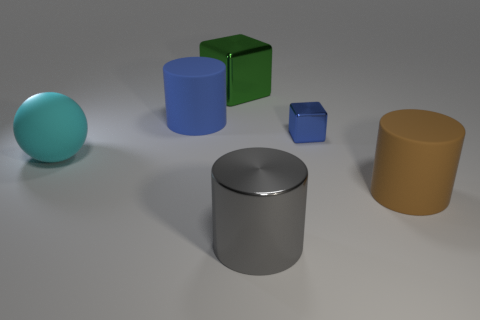Are there any other things that are the same color as the small thing?
Provide a succinct answer. Yes. There is a cylinder that is behind the tiny blue shiny object; does it have the same color as the cube that is in front of the blue matte cylinder?
Provide a short and direct response. Yes. Are there any big green blocks that have the same material as the large blue object?
Your answer should be very brief. No. Is the material of the gray object that is to the right of the green block the same as the green cube?
Your answer should be compact. Yes. There is a metal object that is both in front of the big blue rubber object and behind the big cyan object; what size is it?
Offer a very short reply. Small. The tiny metallic cube has what color?
Provide a succinct answer. Blue. How many big gray matte cylinders are there?
Make the answer very short. 0. How many large matte cylinders are the same color as the small metal cube?
Ensure brevity in your answer.  1. There is a thing in front of the large brown cylinder; does it have the same shape as the big rubber thing that is in front of the big cyan ball?
Your response must be concise. Yes. There is a large object in front of the matte cylinder in front of the cylinder behind the brown cylinder; what is its color?
Provide a succinct answer. Gray. 